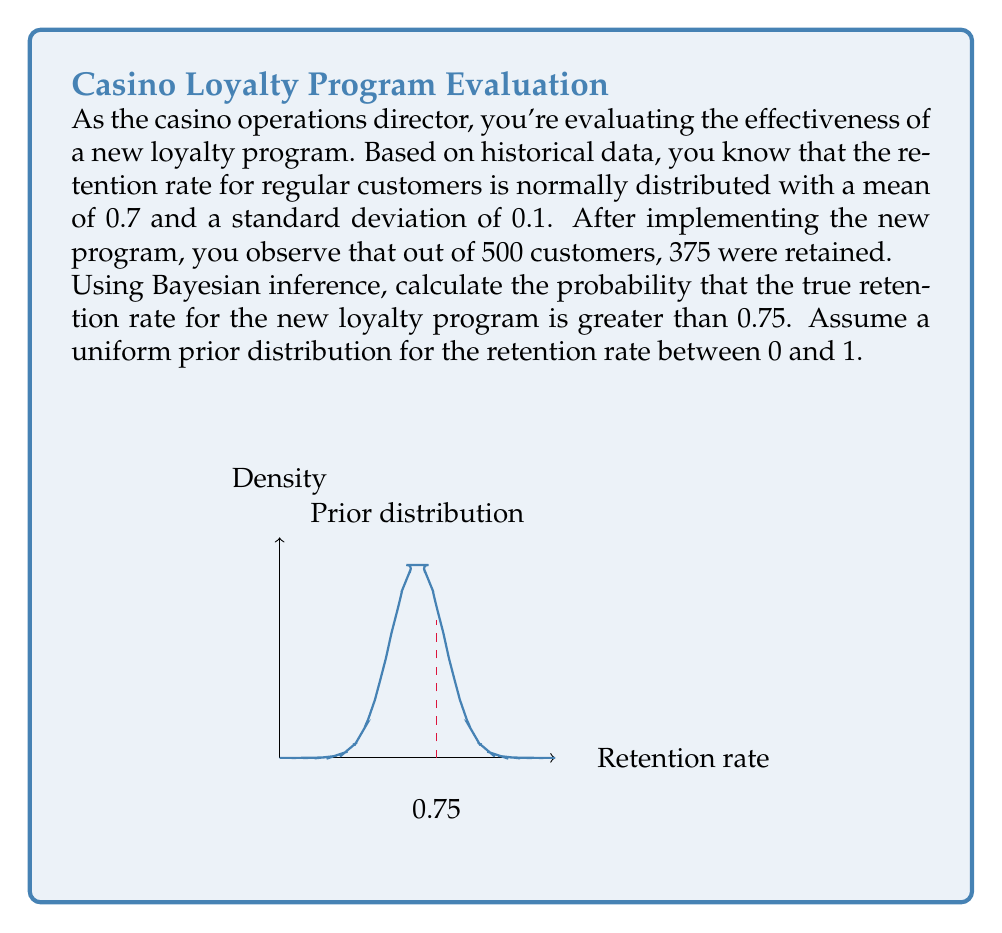Can you answer this question? Let's approach this step-by-step using Bayesian inference:

1) Let $\theta$ be the true retention rate for the new program.

2) Prior: We assume a uniform prior on [0,1], so $p(\theta) = 1$ for $0 \leq \theta \leq 1$.

3) Likelihood: The number of retained customers follows a Binomial distribution. 
   $p(data|\theta) = \binom{500}{375}\theta^{375}(1-\theta)^{125}$

4) Posterior: $p(\theta|data) \propto p(data|\theta)p(\theta)$
   $p(\theta|data) \propto \theta^{375}(1-\theta)^{125}$

5) This is a Beta distribution with parameters $\alpha = 376$ and $\beta = 126$.

6) We need to calculate $P(\theta > 0.75|data)$:
   $P(\theta > 0.75|data) = 1 - P(\theta \leq 0.75|data)$

7) $P(\theta \leq 0.75|data)$ is the cumulative distribution function (CDF) of the Beta(376,126) distribution at 0.75.

8) Using a statistical software or Beta distribution calculator:
   $P(\theta \leq 0.75|data) \approx 0.9992$

9) Therefore, $P(\theta > 0.75|data) = 1 - 0.9992 = 0.0008$

The probability that the true retention rate for the new loyalty program is greater than 0.75 is approximately 0.0008 or 0.08%.
Answer: 0.0008 